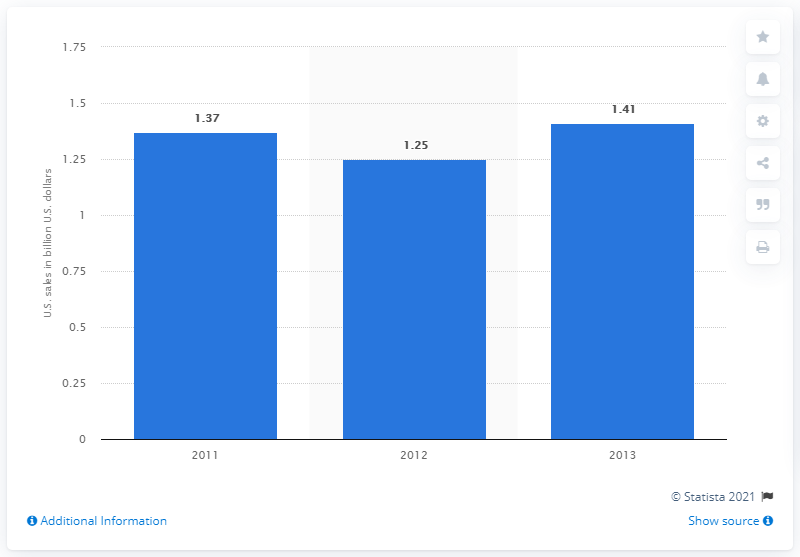Identify some key points in this picture. In 2013, Texas Roadhouse's U.S. sales were 1.41 billion dollars. 